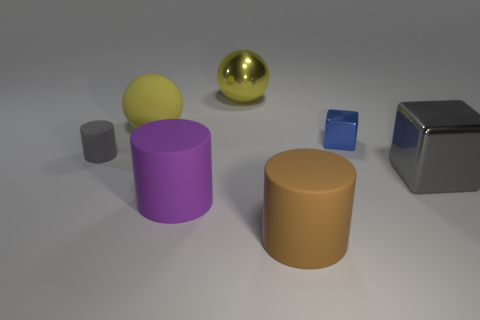Subtract all purple matte cylinders. How many cylinders are left? 2 Add 1 big cyan rubber spheres. How many objects exist? 8 Subtract all spheres. How many objects are left? 5 Subtract all yellow cylinders. Subtract all yellow blocks. How many cylinders are left? 3 Subtract 0 brown blocks. How many objects are left? 7 Subtract all tiny gray shiny balls. Subtract all large metallic things. How many objects are left? 5 Add 7 big gray objects. How many big gray objects are left? 8 Add 3 gray metal objects. How many gray metal objects exist? 4 